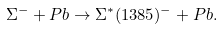Convert formula to latex. <formula><loc_0><loc_0><loc_500><loc_500>\Sigma ^ { - } + P b \to \Sigma ^ { * } ( 1 3 8 5 ) ^ { - } + P b .</formula> 